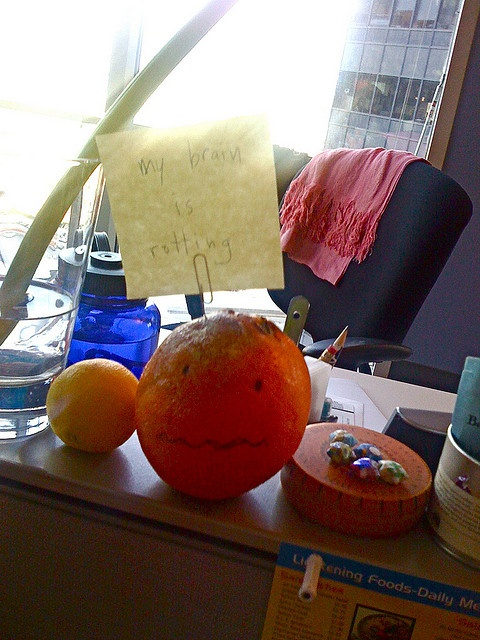Describe the objects in this image and their specific colors. I can see chair in white, black, brown, and maroon tones, orange in white, maroon, brown, and gray tones, cup in white, gray, and darkgray tones, bottle in white, darkblue, blue, navy, and black tones, and orange in white, maroon, brown, and olive tones in this image. 